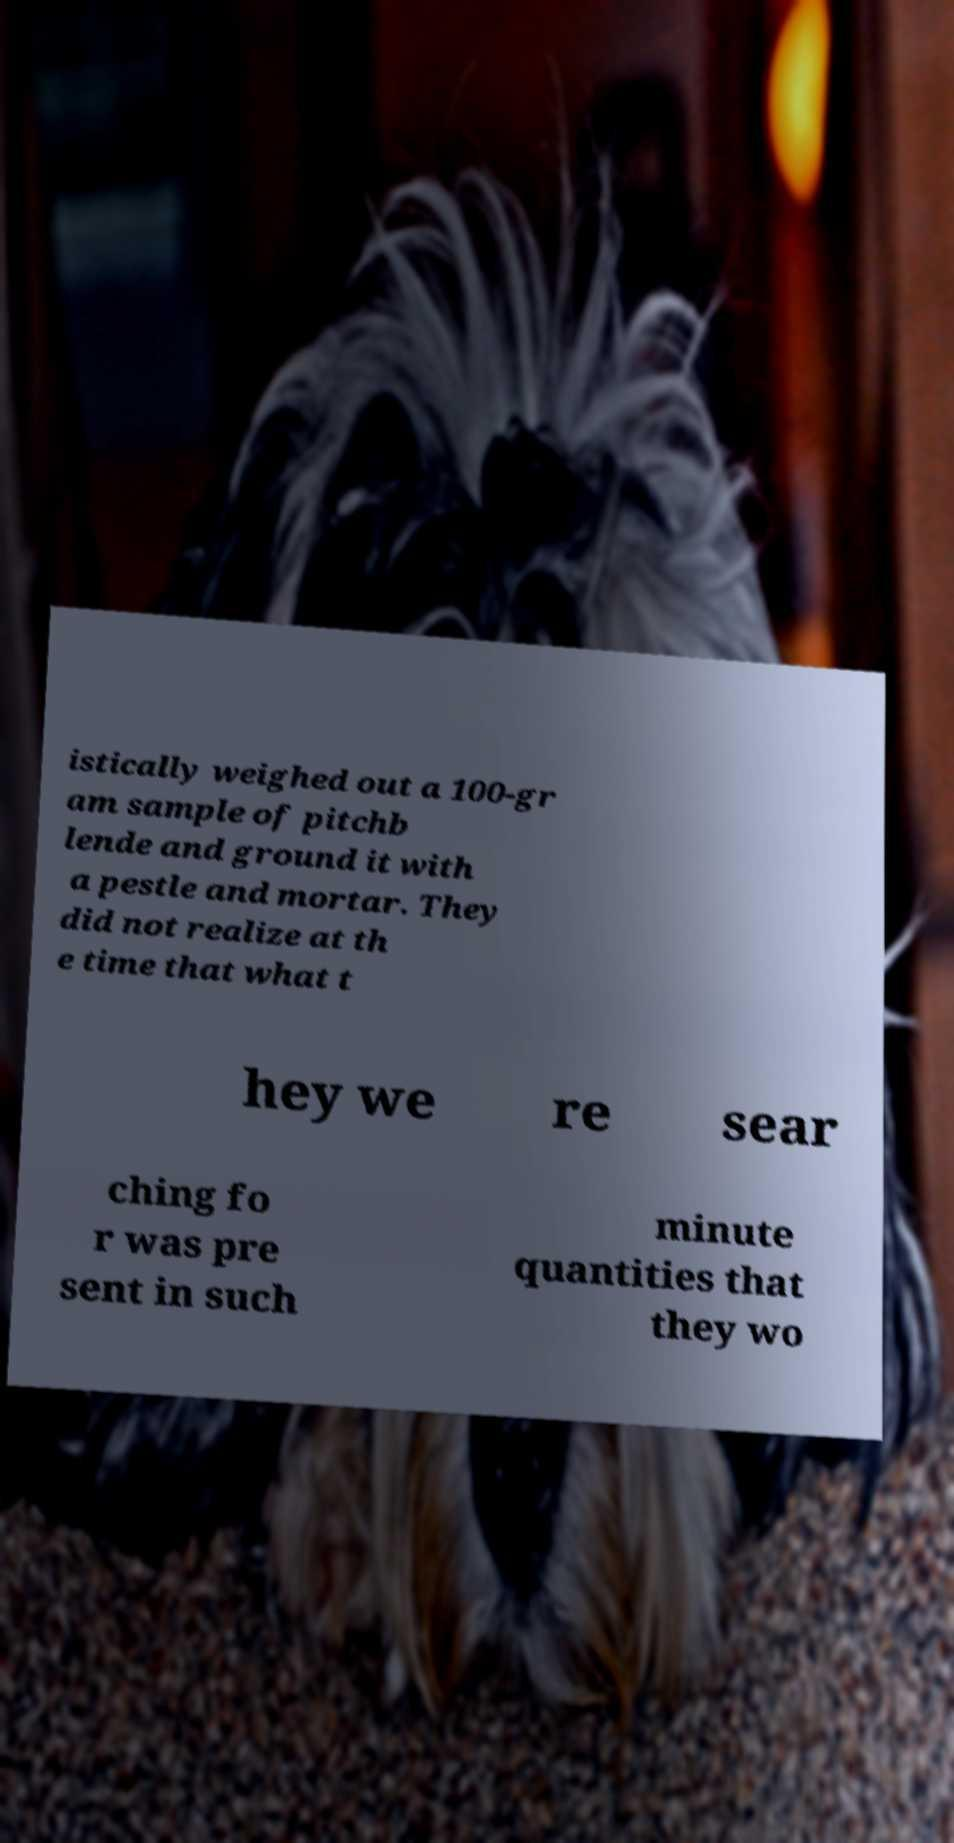Can you accurately transcribe the text from the provided image for me? istically weighed out a 100-gr am sample of pitchb lende and ground it with a pestle and mortar. They did not realize at th e time that what t hey we re sear ching fo r was pre sent in such minute quantities that they wo 